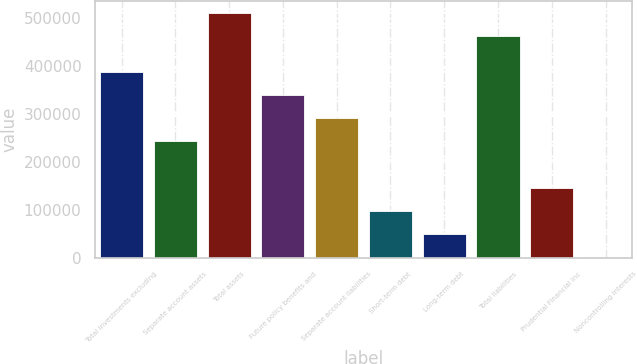Convert chart. <chart><loc_0><loc_0><loc_500><loc_500><bar_chart><fcel>Total investments excluding<fcel>Separate account assets<fcel>Total assets<fcel>Future policy benefits and<fcel>Separate account liabilities<fcel>Short-term debt<fcel>Long-term debt<fcel>Total liabilities<fcel>Prudential Financial Inc<fcel>Noncontrolling interests<nl><fcel>388732<fcel>243111<fcel>510430<fcel>340192<fcel>291651<fcel>97489.8<fcel>48949.4<fcel>461890<fcel>146030<fcel>409<nl></chart> 